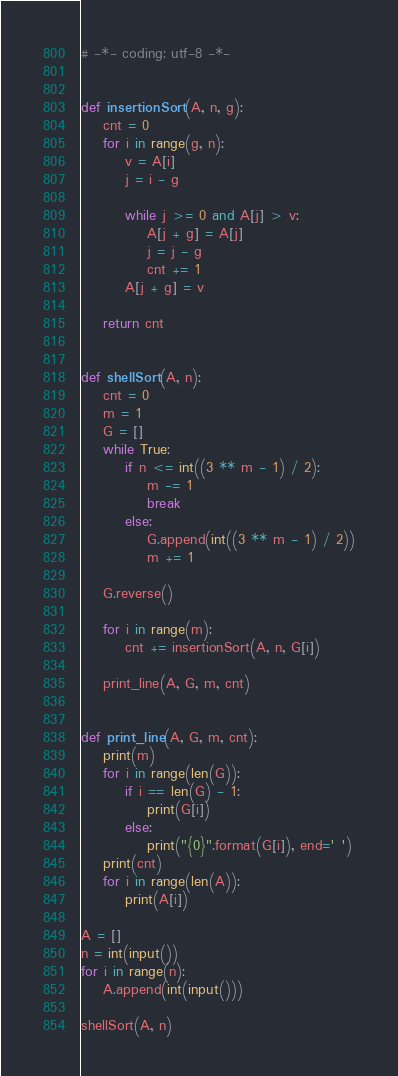Convert code to text. <code><loc_0><loc_0><loc_500><loc_500><_Python_># -*- coding: utf-8 -*-


def insertionSort(A, n, g):
    cnt = 0
    for i in range(g, n):
        v = A[i]
        j = i - g

        while j >= 0 and A[j] > v:
            A[j + g] = A[j]
            j = j - g
            cnt += 1
        A[j + g] = v

    return cnt


def shellSort(A, n):
    cnt = 0
    m = 1
    G = []
    while True:
        if n <= int((3 ** m - 1) / 2):
            m -= 1
            break
        else:
            G.append(int((3 ** m - 1) / 2))
            m += 1

    G.reverse()

    for i in range(m):
        cnt += insertionSort(A, n, G[i])

    print_line(A, G, m, cnt)


def print_line(A, G, m, cnt):
    print(m)
    for i in range(len(G)):
        if i == len(G) - 1:
            print(G[i])
        else:
            print("{0}".format(G[i]), end=' ')
    print(cnt)
    for i in range(len(A)):
        print(A[i])

A = []
n = int(input())
for i in range(n):
    A.append(int(input()))

shellSort(A, n)
</code> 